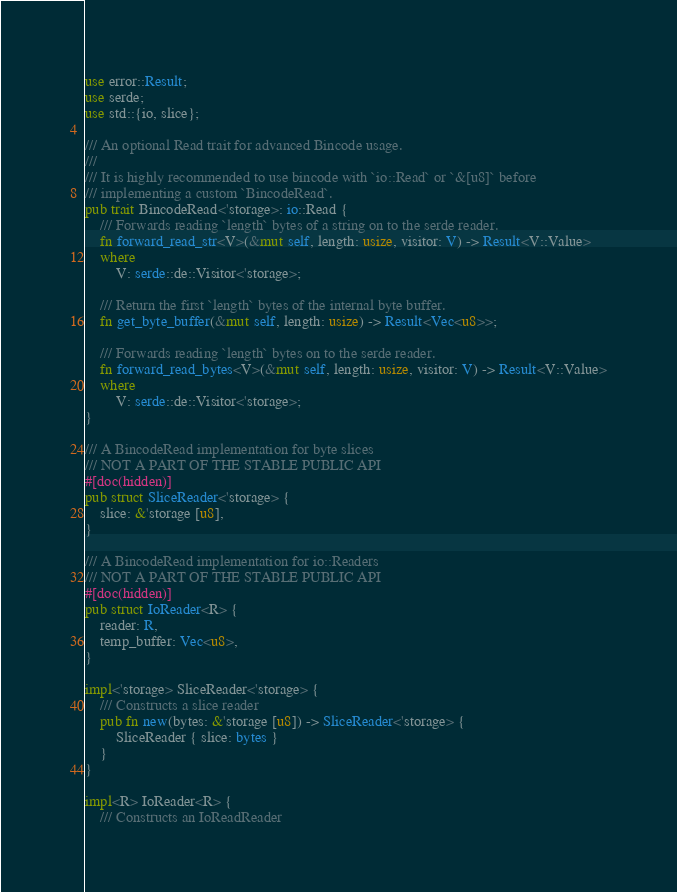Convert code to text. <code><loc_0><loc_0><loc_500><loc_500><_Rust_>use error::Result;
use serde;
use std::{io, slice};

/// An optional Read trait for advanced Bincode usage.
///
/// It is highly recommended to use bincode with `io::Read` or `&[u8]` before
/// implementing a custom `BincodeRead`.
pub trait BincodeRead<'storage>: io::Read {
    /// Forwards reading `length` bytes of a string on to the serde reader.
    fn forward_read_str<V>(&mut self, length: usize, visitor: V) -> Result<V::Value>
    where
        V: serde::de::Visitor<'storage>;

    /// Return the first `length` bytes of the internal byte buffer.
    fn get_byte_buffer(&mut self, length: usize) -> Result<Vec<u8>>;

    /// Forwards reading `length` bytes on to the serde reader.
    fn forward_read_bytes<V>(&mut self, length: usize, visitor: V) -> Result<V::Value>
    where
        V: serde::de::Visitor<'storage>;
}

/// A BincodeRead implementation for byte slices
/// NOT A PART OF THE STABLE PUBLIC API
#[doc(hidden)]
pub struct SliceReader<'storage> {
    slice: &'storage [u8],
}

/// A BincodeRead implementation for io::Readers
/// NOT A PART OF THE STABLE PUBLIC API
#[doc(hidden)]
pub struct IoReader<R> {
    reader: R,
    temp_buffer: Vec<u8>,
}

impl<'storage> SliceReader<'storage> {
    /// Constructs a slice reader
    pub fn new(bytes: &'storage [u8]) -> SliceReader<'storage> {
        SliceReader { slice: bytes }
    }
}

impl<R> IoReader<R> {
    /// Constructs an IoReadReader</code> 